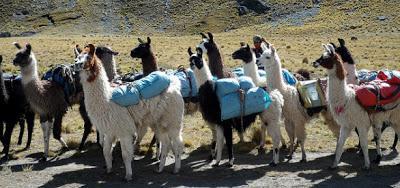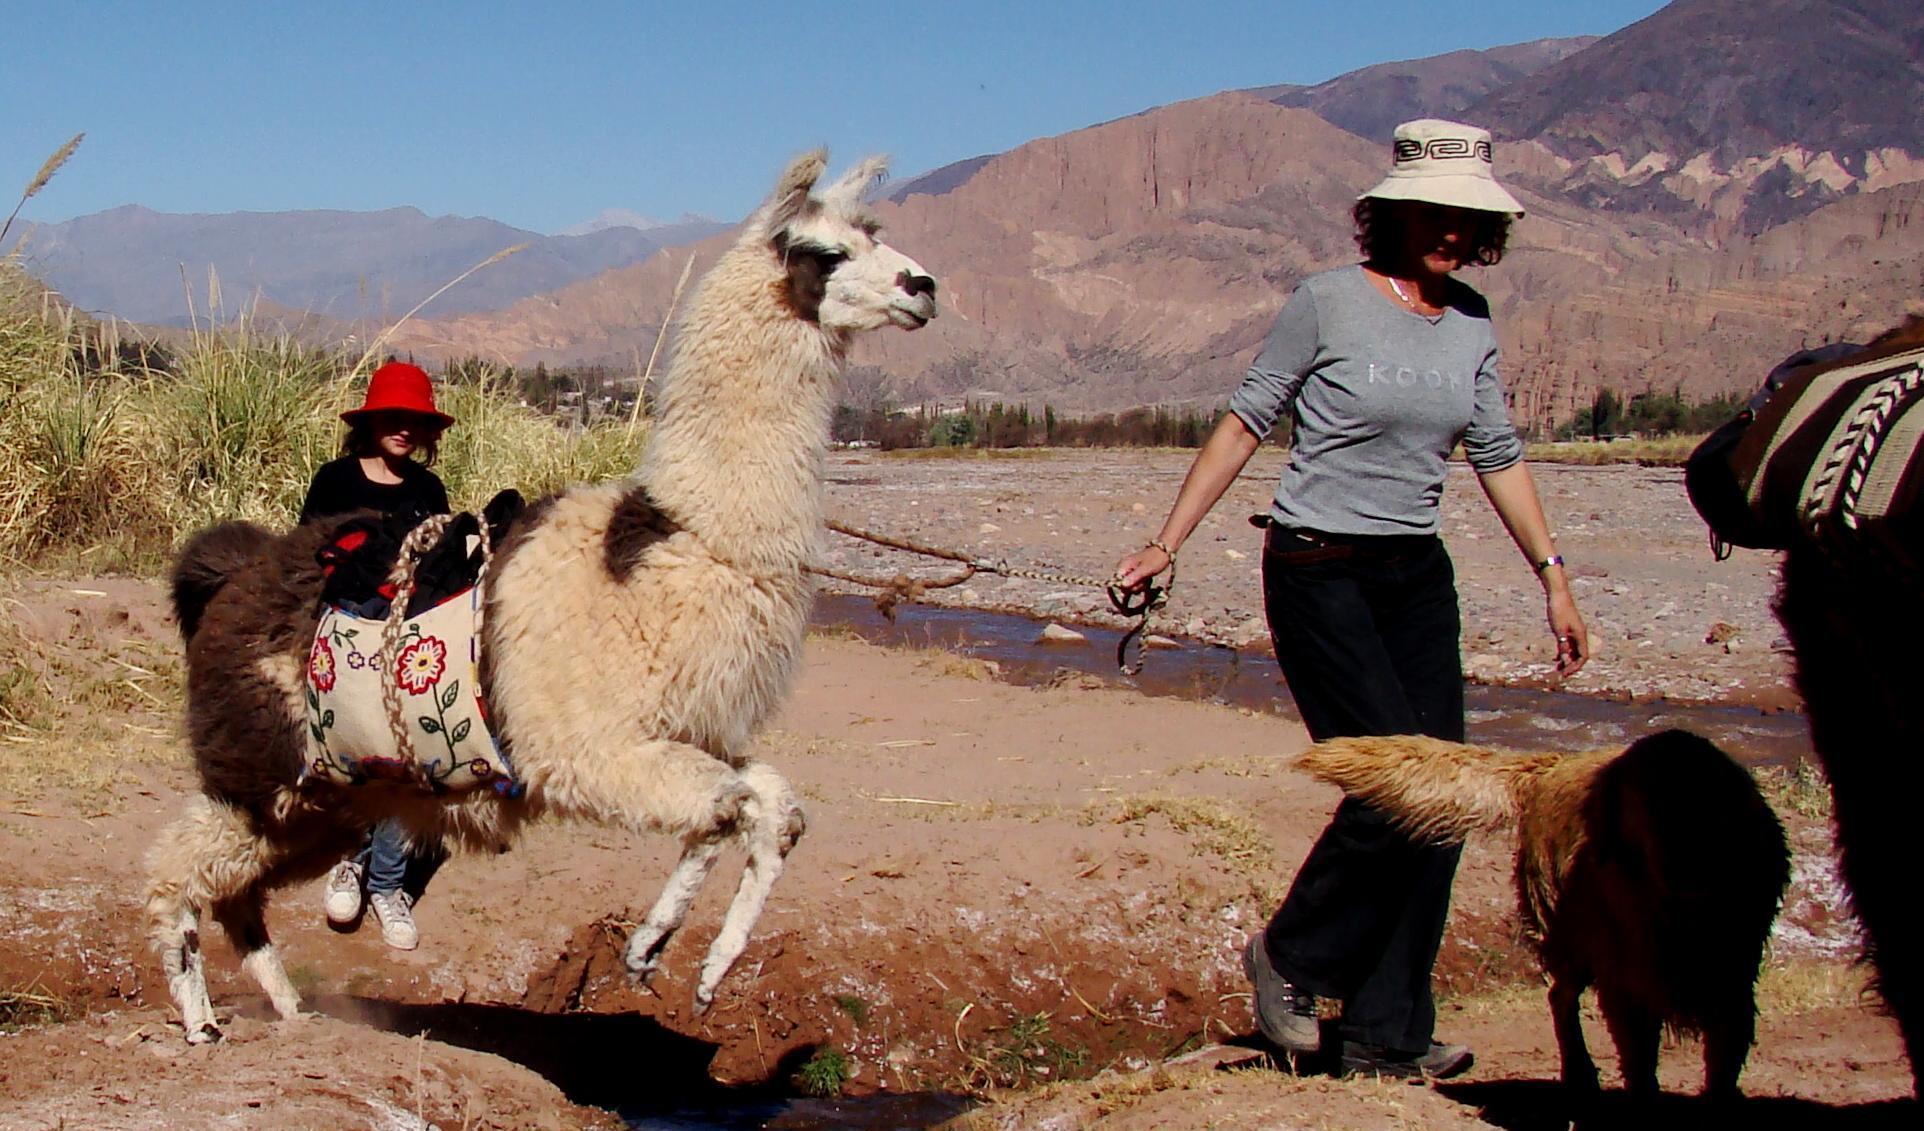The first image is the image on the left, the second image is the image on the right. Considering the images on both sides, is "The right image includes a person leading a llama toward the camera, and the left image includes multiple llamas wearing packs." valid? Answer yes or no. Yes. 